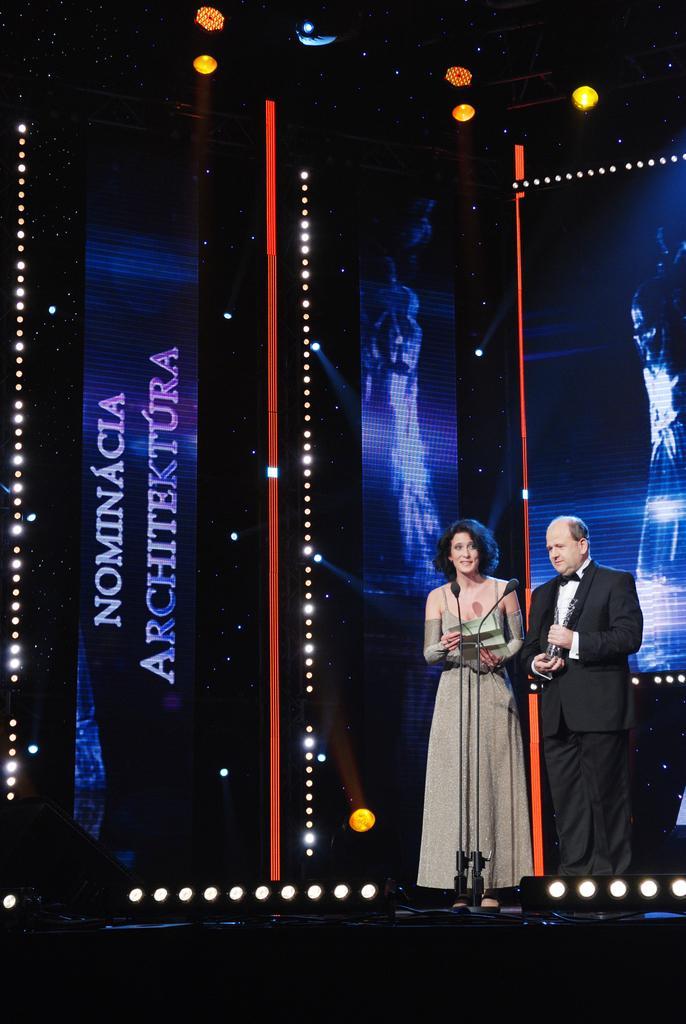Describe this image in one or two sentences. In the center of the image there are two people standing on the stage. In the background of the image there is a screen. There is a mic. At the top of the image there are lights. 